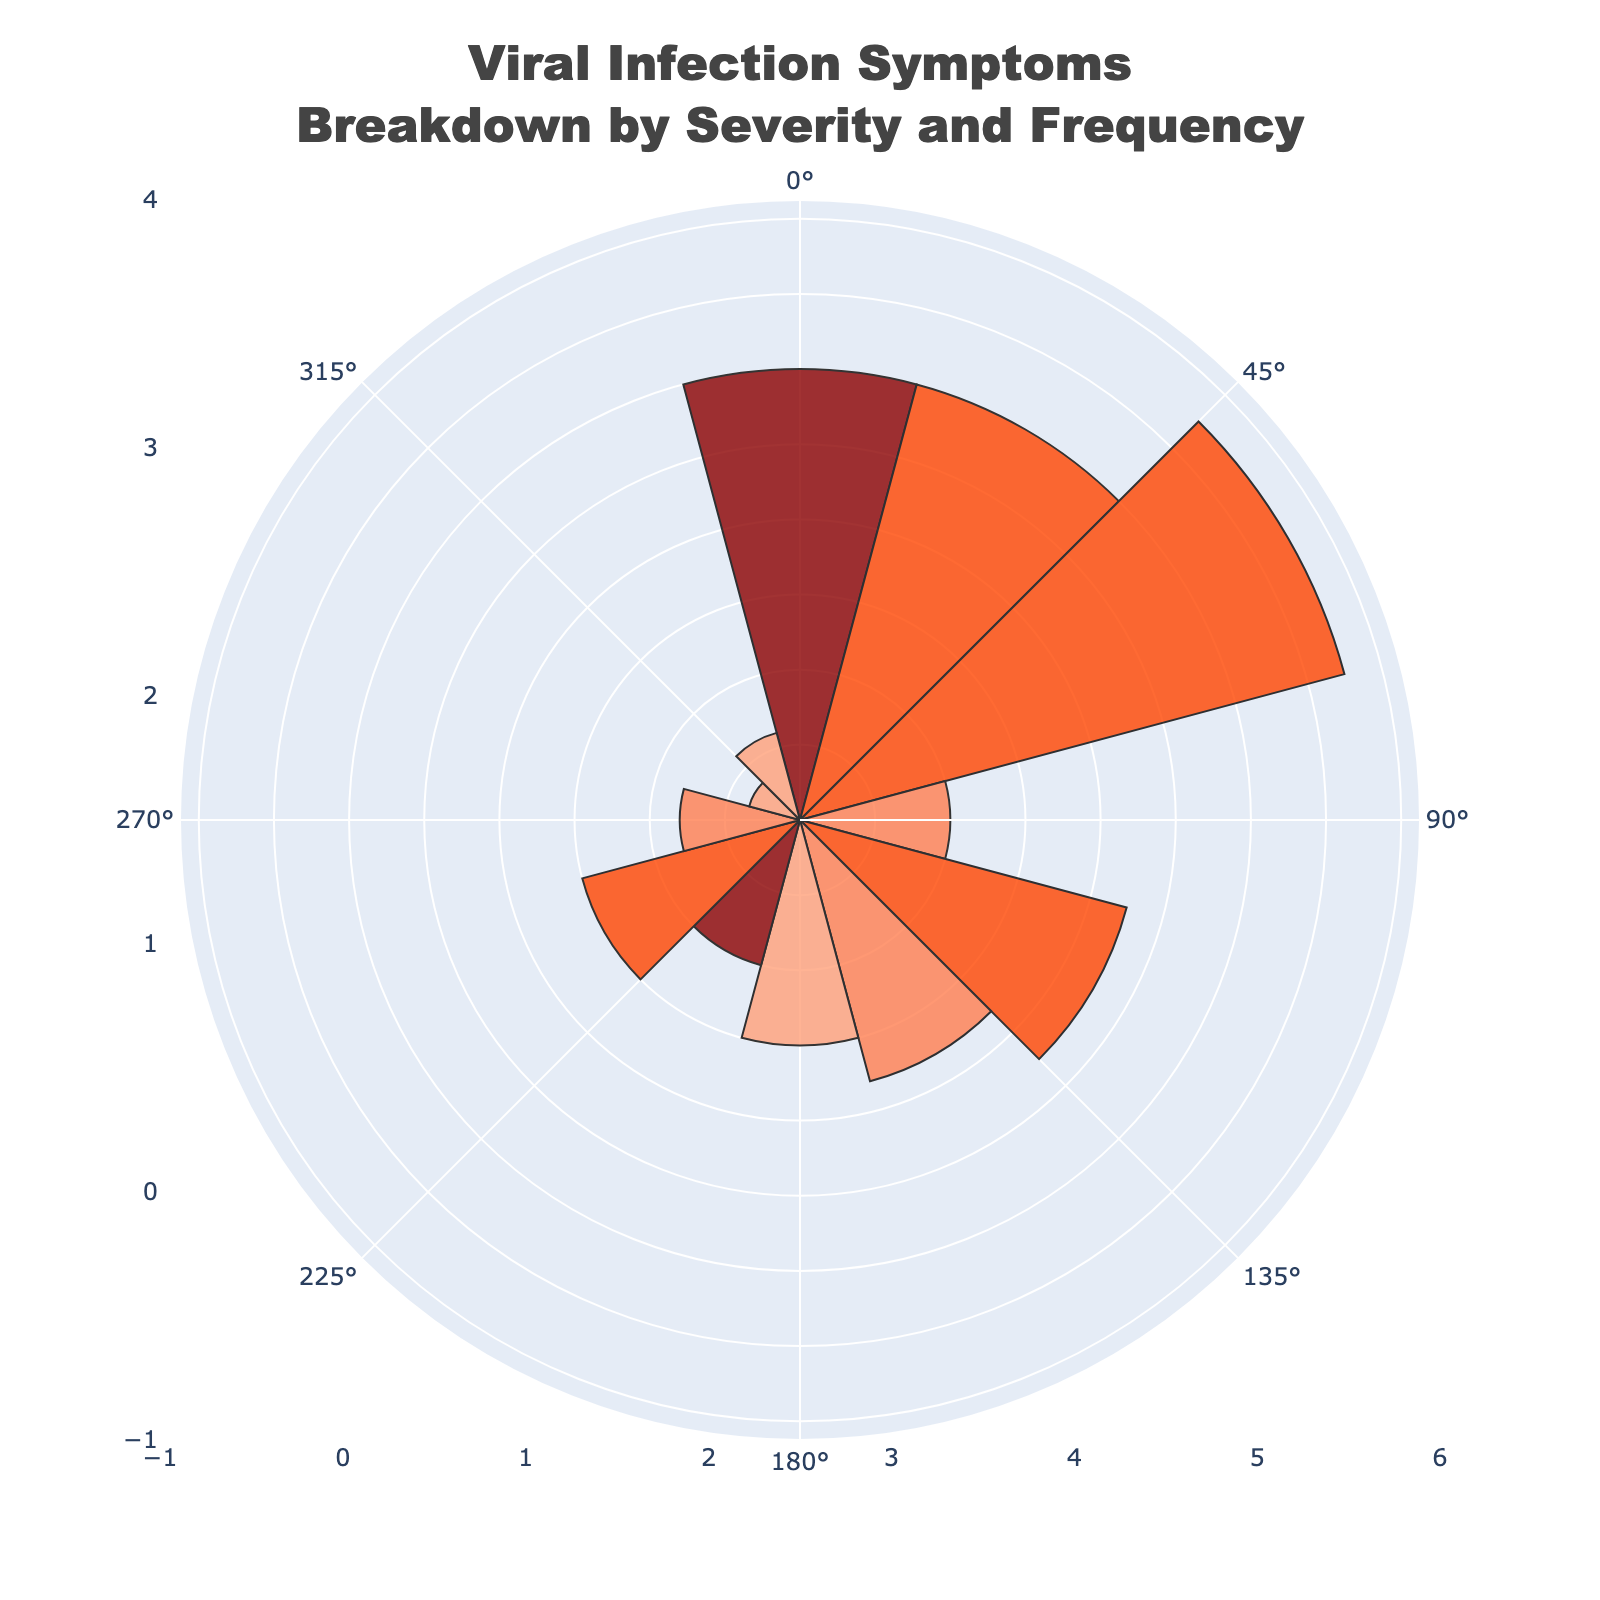How many symptoms are categorized under "Moderate" severity? Count the number of symptoms with "Moderate" severity from the figure.
Answer: 4 Which symptom has the highest frequency? Identify the symptom with the largest radial slice indicating frequency.
Answer: Runny Nose What is the combined frequency of symptoms with "High" severity? Add the frequencies of symptoms listed under "High" severity.
Answer: 15 + 5 = 20 Which symptoms have the smallest and largest sizes respectively? Identify the symptoms with the smallest and largest radial value or size.
Answer: Diarrhea (smallest), Fatigue (largest) Does "Fever" or "Muscle Pain" have a higher frequency? Compare the frequency values for "Fever" and "Muscle Pain".
Answer: Muscle Pain Which severity category has the most symptoms? Count the number of symptoms in each severity category and identify the one with the most.
Answer: Moderate What is the median frequency for all the symptoms displayed? Arrange the frequency values in ascending order and find the middle value.
Answer: 15 How does the frequency of "Cough" compare with "Headache"? Compare the frequency values directly from the figure.
Answer: Cough Which severity color represents the most frequent symptom? Look at the color coding for severity categories and match it with the most frequent radial slice.
Answer: Low What is a unique characteristic of the figures' polar layout? Describe a distinct visual or structural characteristic specific to the rose chart.
Answer: Radial slices represent severity and angle represents symptom 